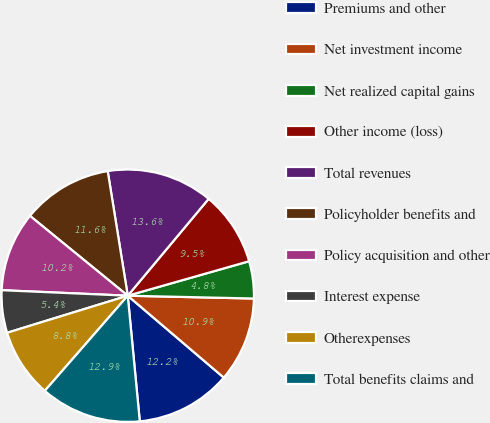<chart> <loc_0><loc_0><loc_500><loc_500><pie_chart><fcel>Premiums and other<fcel>Net investment income<fcel>Net realized capital gains<fcel>Other income (loss)<fcel>Total revenues<fcel>Policyholder benefits and<fcel>Policy acquisition and other<fcel>Interest expense<fcel>Otherexpenses<fcel>Total benefits claims and<nl><fcel>12.24%<fcel>10.88%<fcel>4.76%<fcel>9.52%<fcel>13.61%<fcel>11.56%<fcel>10.2%<fcel>5.44%<fcel>8.84%<fcel>12.93%<nl></chart> 